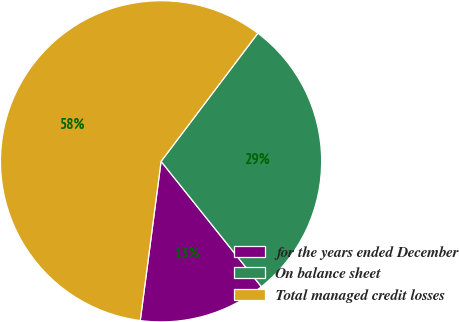<chart> <loc_0><loc_0><loc_500><loc_500><pie_chart><fcel>for the years ended December<fcel>On balance sheet<fcel>Total managed credit losses<nl><fcel>12.81%<fcel>28.96%<fcel>58.23%<nl></chart> 